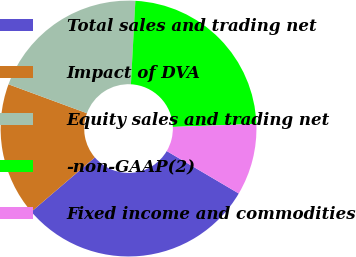Convert chart. <chart><loc_0><loc_0><loc_500><loc_500><pie_chart><fcel>Total sales and trading net<fcel>Impact of DVA<fcel>Equity sales and trading net<fcel>-non-GAAP(2)<fcel>Fixed income and commodities<nl><fcel>30.26%<fcel>16.89%<fcel>20.23%<fcel>23.57%<fcel>9.05%<nl></chart> 